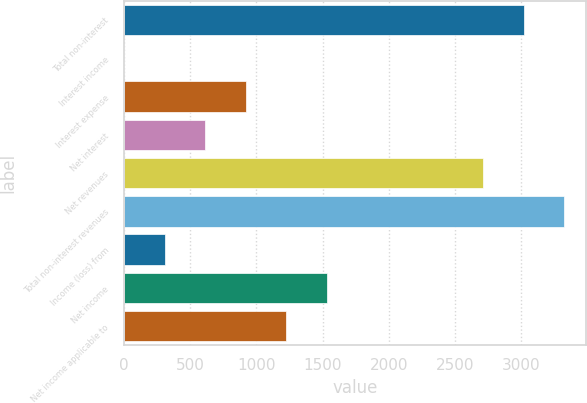Convert chart. <chart><loc_0><loc_0><loc_500><loc_500><bar_chart><fcel>Total non-interest<fcel>Interest income<fcel>Interest expense<fcel>Net interest<fcel>Net revenues<fcel>Total non-interest revenues<fcel>Income (loss) from<fcel>Net income<fcel>Net income applicable to<nl><fcel>3017.8<fcel>2<fcel>919.4<fcel>613.6<fcel>2712<fcel>3323.6<fcel>307.8<fcel>1531<fcel>1225.2<nl></chart> 